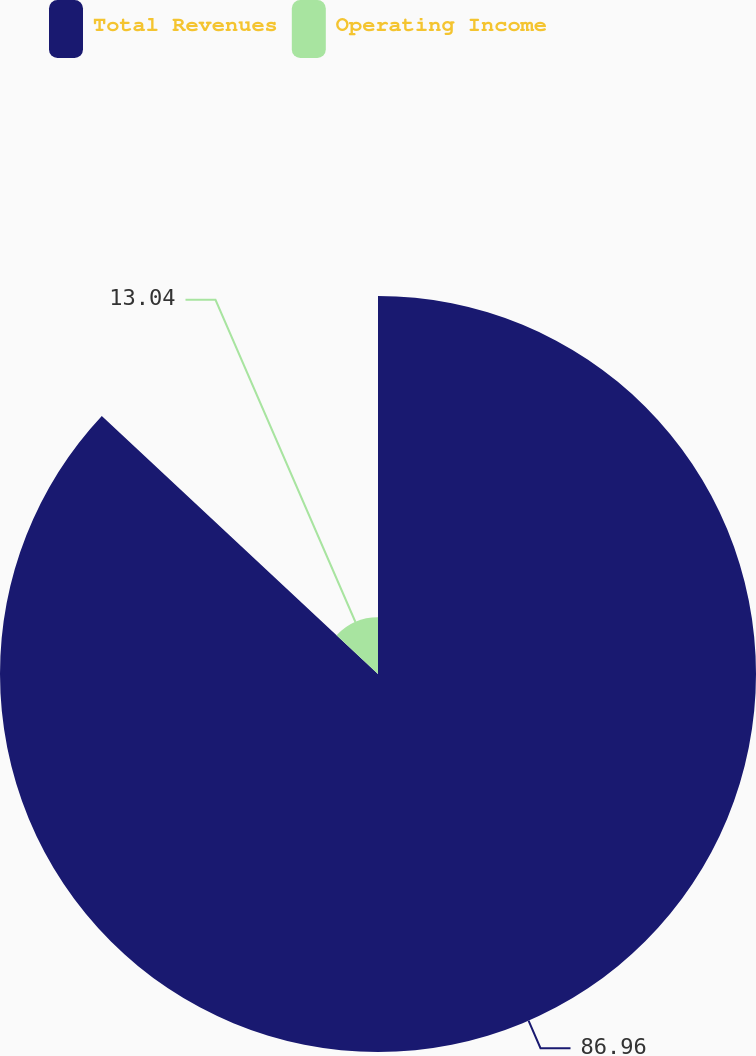Convert chart. <chart><loc_0><loc_0><loc_500><loc_500><pie_chart><fcel>Total Revenues<fcel>Operating Income<nl><fcel>86.96%<fcel>13.04%<nl></chart> 